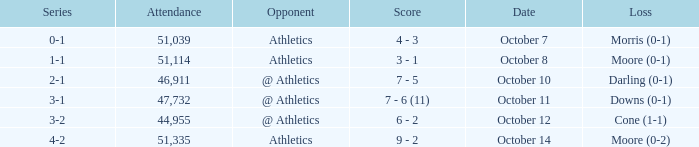Would you be able to parse every entry in this table? {'header': ['Series', 'Attendance', 'Opponent', 'Score', 'Date', 'Loss'], 'rows': [['0-1', '51,039', 'Athletics', '4 - 3', 'October 7', 'Morris (0-1)'], ['1-1', '51,114', 'Athletics', '3 - 1', 'October 8', 'Moore (0-1)'], ['2-1', '46,911', '@ Athletics', '7 - 5', 'October 10', 'Darling (0-1)'], ['3-1', '47,732', '@ Athletics', '7 - 6 (11)', 'October 11', 'Downs (0-1)'], ['3-2', '44,955', '@ Athletics', '6 - 2', 'October 12', 'Cone (1-1)'], ['4-2', '51,335', 'Athletics', '9 - 2', 'October 14', 'Moore (0-2)']]} When was the game with the loss of Moore (0-1)? October 8. 